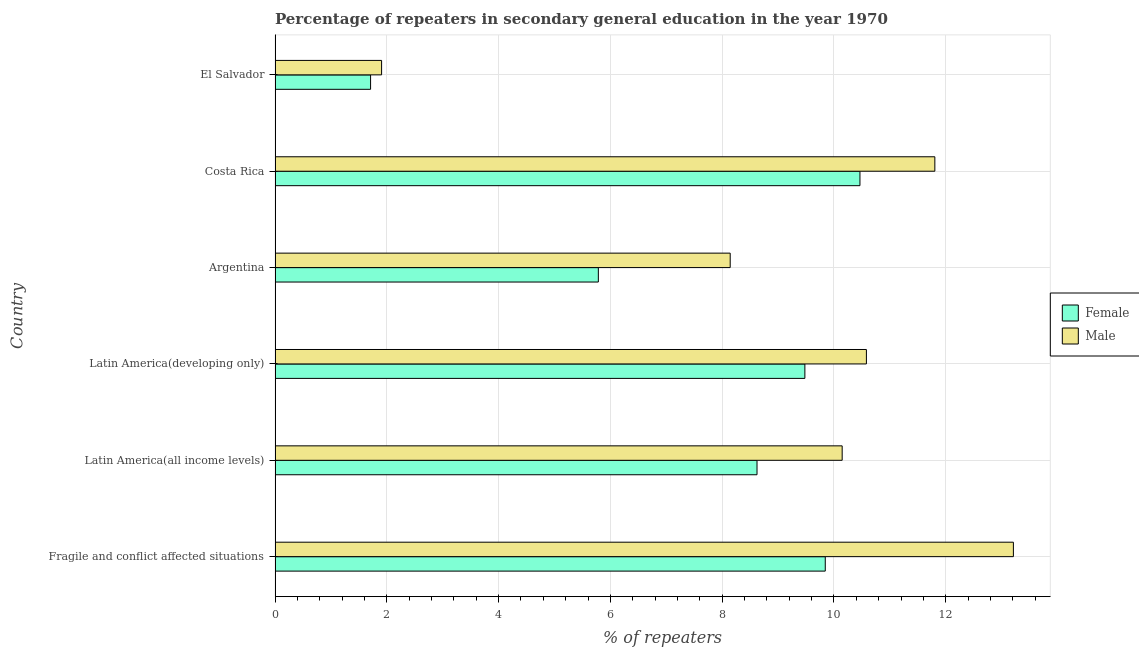How many different coloured bars are there?
Provide a short and direct response. 2. How many groups of bars are there?
Make the answer very short. 6. How many bars are there on the 5th tick from the bottom?
Make the answer very short. 2. In how many cases, is the number of bars for a given country not equal to the number of legend labels?
Provide a short and direct response. 0. What is the percentage of male repeaters in El Salvador?
Give a very brief answer. 1.91. Across all countries, what is the maximum percentage of female repeaters?
Ensure brevity in your answer.  10.47. Across all countries, what is the minimum percentage of male repeaters?
Make the answer very short. 1.91. In which country was the percentage of female repeaters minimum?
Your answer should be very brief. El Salvador. What is the total percentage of male repeaters in the graph?
Offer a very short reply. 55.79. What is the difference between the percentage of female repeaters in Costa Rica and that in Latin America(all income levels)?
Offer a terse response. 1.84. What is the difference between the percentage of female repeaters in Argentina and the percentage of male repeaters in Fragile and conflict affected situations?
Your answer should be very brief. -7.43. What is the average percentage of female repeaters per country?
Ensure brevity in your answer.  7.65. What is the difference between the percentage of female repeaters and percentage of male repeaters in Latin America(developing only)?
Offer a terse response. -1.1. What is the ratio of the percentage of male repeaters in El Salvador to that in Fragile and conflict affected situations?
Ensure brevity in your answer.  0.14. Is the percentage of female repeaters in El Salvador less than that in Latin America(developing only)?
Offer a terse response. Yes. What is the difference between the highest and the second highest percentage of female repeaters?
Provide a succinct answer. 0.62. What is the difference between the highest and the lowest percentage of female repeaters?
Offer a terse response. 8.76. In how many countries, is the percentage of female repeaters greater than the average percentage of female repeaters taken over all countries?
Make the answer very short. 4. Is the sum of the percentage of male repeaters in El Salvador and Latin America(all income levels) greater than the maximum percentage of female repeaters across all countries?
Keep it short and to the point. Yes. What does the 1st bar from the bottom in Costa Rica represents?
Ensure brevity in your answer.  Female. How many bars are there?
Your answer should be compact. 12. How many countries are there in the graph?
Ensure brevity in your answer.  6. What is the difference between two consecutive major ticks on the X-axis?
Give a very brief answer. 2. Are the values on the major ticks of X-axis written in scientific E-notation?
Your answer should be very brief. No. Does the graph contain any zero values?
Provide a short and direct response. No. How many legend labels are there?
Provide a short and direct response. 2. How are the legend labels stacked?
Your answer should be compact. Vertical. What is the title of the graph?
Your response must be concise. Percentage of repeaters in secondary general education in the year 1970. Does "Official aid received" appear as one of the legend labels in the graph?
Your answer should be very brief. No. What is the label or title of the X-axis?
Your answer should be compact. % of repeaters. What is the label or title of the Y-axis?
Your answer should be compact. Country. What is the % of repeaters in Female in Fragile and conflict affected situations?
Your response must be concise. 9.84. What is the % of repeaters in Male in Fragile and conflict affected situations?
Keep it short and to the point. 13.21. What is the % of repeaters of Female in Latin America(all income levels)?
Provide a succinct answer. 8.62. What is the % of repeaters in Male in Latin America(all income levels)?
Provide a short and direct response. 10.15. What is the % of repeaters in Female in Latin America(developing only)?
Your answer should be very brief. 9.48. What is the % of repeaters in Male in Latin America(developing only)?
Offer a very short reply. 10.58. What is the % of repeaters of Female in Argentina?
Your answer should be very brief. 5.78. What is the % of repeaters in Male in Argentina?
Give a very brief answer. 8.14. What is the % of repeaters in Female in Costa Rica?
Keep it short and to the point. 10.47. What is the % of repeaters of Male in Costa Rica?
Your answer should be very brief. 11.81. What is the % of repeaters in Female in El Salvador?
Offer a very short reply. 1.71. What is the % of repeaters in Male in El Salvador?
Keep it short and to the point. 1.91. Across all countries, what is the maximum % of repeaters in Female?
Offer a very short reply. 10.47. Across all countries, what is the maximum % of repeaters in Male?
Your answer should be very brief. 13.21. Across all countries, what is the minimum % of repeaters in Female?
Offer a terse response. 1.71. Across all countries, what is the minimum % of repeaters in Male?
Your answer should be very brief. 1.91. What is the total % of repeaters in Female in the graph?
Make the answer very short. 45.91. What is the total % of repeaters in Male in the graph?
Make the answer very short. 55.79. What is the difference between the % of repeaters of Female in Fragile and conflict affected situations and that in Latin America(all income levels)?
Keep it short and to the point. 1.22. What is the difference between the % of repeaters in Male in Fragile and conflict affected situations and that in Latin America(all income levels)?
Give a very brief answer. 3.06. What is the difference between the % of repeaters in Female in Fragile and conflict affected situations and that in Latin America(developing only)?
Your answer should be compact. 0.36. What is the difference between the % of repeaters in Male in Fragile and conflict affected situations and that in Latin America(developing only)?
Ensure brevity in your answer.  2.63. What is the difference between the % of repeaters of Female in Fragile and conflict affected situations and that in Argentina?
Make the answer very short. 4.06. What is the difference between the % of repeaters in Male in Fragile and conflict affected situations and that in Argentina?
Provide a succinct answer. 5.07. What is the difference between the % of repeaters of Female in Fragile and conflict affected situations and that in Costa Rica?
Make the answer very short. -0.62. What is the difference between the % of repeaters in Male in Fragile and conflict affected situations and that in Costa Rica?
Give a very brief answer. 1.41. What is the difference between the % of repeaters of Female in Fragile and conflict affected situations and that in El Salvador?
Your answer should be compact. 8.14. What is the difference between the % of repeaters in Male in Fragile and conflict affected situations and that in El Salvador?
Your answer should be compact. 11.31. What is the difference between the % of repeaters of Female in Latin America(all income levels) and that in Latin America(developing only)?
Your answer should be very brief. -0.86. What is the difference between the % of repeaters in Male in Latin America(all income levels) and that in Latin America(developing only)?
Ensure brevity in your answer.  -0.43. What is the difference between the % of repeaters in Female in Latin America(all income levels) and that in Argentina?
Give a very brief answer. 2.84. What is the difference between the % of repeaters of Male in Latin America(all income levels) and that in Argentina?
Ensure brevity in your answer.  2. What is the difference between the % of repeaters of Female in Latin America(all income levels) and that in Costa Rica?
Your answer should be very brief. -1.84. What is the difference between the % of repeaters of Male in Latin America(all income levels) and that in Costa Rica?
Your answer should be compact. -1.66. What is the difference between the % of repeaters in Female in Latin America(all income levels) and that in El Salvador?
Provide a short and direct response. 6.91. What is the difference between the % of repeaters in Male in Latin America(all income levels) and that in El Salvador?
Give a very brief answer. 8.24. What is the difference between the % of repeaters of Female in Latin America(developing only) and that in Argentina?
Make the answer very short. 3.7. What is the difference between the % of repeaters of Male in Latin America(developing only) and that in Argentina?
Your answer should be very brief. 2.44. What is the difference between the % of repeaters in Female in Latin America(developing only) and that in Costa Rica?
Your answer should be compact. -0.99. What is the difference between the % of repeaters of Male in Latin America(developing only) and that in Costa Rica?
Ensure brevity in your answer.  -1.22. What is the difference between the % of repeaters of Female in Latin America(developing only) and that in El Salvador?
Your response must be concise. 7.77. What is the difference between the % of repeaters of Male in Latin America(developing only) and that in El Salvador?
Make the answer very short. 8.68. What is the difference between the % of repeaters in Female in Argentina and that in Costa Rica?
Your answer should be very brief. -4.68. What is the difference between the % of repeaters in Male in Argentina and that in Costa Rica?
Your response must be concise. -3.66. What is the difference between the % of repeaters of Female in Argentina and that in El Salvador?
Your answer should be compact. 4.08. What is the difference between the % of repeaters of Male in Argentina and that in El Salvador?
Give a very brief answer. 6.24. What is the difference between the % of repeaters in Female in Costa Rica and that in El Salvador?
Keep it short and to the point. 8.76. What is the difference between the % of repeaters of Male in Costa Rica and that in El Salvador?
Make the answer very short. 9.9. What is the difference between the % of repeaters in Female in Fragile and conflict affected situations and the % of repeaters in Male in Latin America(all income levels)?
Provide a short and direct response. -0.3. What is the difference between the % of repeaters of Female in Fragile and conflict affected situations and the % of repeaters of Male in Latin America(developing only)?
Provide a short and direct response. -0.74. What is the difference between the % of repeaters of Female in Fragile and conflict affected situations and the % of repeaters of Male in Argentina?
Offer a very short reply. 1.7. What is the difference between the % of repeaters in Female in Fragile and conflict affected situations and the % of repeaters in Male in Costa Rica?
Give a very brief answer. -1.96. What is the difference between the % of repeaters in Female in Fragile and conflict affected situations and the % of repeaters in Male in El Salvador?
Make the answer very short. 7.94. What is the difference between the % of repeaters of Female in Latin America(all income levels) and the % of repeaters of Male in Latin America(developing only)?
Offer a very short reply. -1.96. What is the difference between the % of repeaters in Female in Latin America(all income levels) and the % of repeaters in Male in Argentina?
Keep it short and to the point. 0.48. What is the difference between the % of repeaters in Female in Latin America(all income levels) and the % of repeaters in Male in Costa Rica?
Offer a terse response. -3.18. What is the difference between the % of repeaters of Female in Latin America(all income levels) and the % of repeaters of Male in El Salvador?
Offer a very short reply. 6.72. What is the difference between the % of repeaters in Female in Latin America(developing only) and the % of repeaters in Male in Argentina?
Your answer should be compact. 1.34. What is the difference between the % of repeaters in Female in Latin America(developing only) and the % of repeaters in Male in Costa Rica?
Offer a terse response. -2.33. What is the difference between the % of repeaters in Female in Latin America(developing only) and the % of repeaters in Male in El Salvador?
Offer a very short reply. 7.57. What is the difference between the % of repeaters of Female in Argentina and the % of repeaters of Male in Costa Rica?
Your answer should be very brief. -6.02. What is the difference between the % of repeaters in Female in Argentina and the % of repeaters in Male in El Salvador?
Keep it short and to the point. 3.88. What is the difference between the % of repeaters of Female in Costa Rica and the % of repeaters of Male in El Salvador?
Your answer should be very brief. 8.56. What is the average % of repeaters in Female per country?
Make the answer very short. 7.65. What is the average % of repeaters in Male per country?
Keep it short and to the point. 9.3. What is the difference between the % of repeaters in Female and % of repeaters in Male in Fragile and conflict affected situations?
Your answer should be very brief. -3.37. What is the difference between the % of repeaters of Female and % of repeaters of Male in Latin America(all income levels)?
Provide a succinct answer. -1.52. What is the difference between the % of repeaters in Female and % of repeaters in Male in Latin America(developing only)?
Your answer should be compact. -1.1. What is the difference between the % of repeaters of Female and % of repeaters of Male in Argentina?
Give a very brief answer. -2.36. What is the difference between the % of repeaters in Female and % of repeaters in Male in Costa Rica?
Keep it short and to the point. -1.34. What is the difference between the % of repeaters of Female and % of repeaters of Male in El Salvador?
Provide a short and direct response. -0.2. What is the ratio of the % of repeaters in Female in Fragile and conflict affected situations to that in Latin America(all income levels)?
Keep it short and to the point. 1.14. What is the ratio of the % of repeaters of Male in Fragile and conflict affected situations to that in Latin America(all income levels)?
Your response must be concise. 1.3. What is the ratio of the % of repeaters of Female in Fragile and conflict affected situations to that in Latin America(developing only)?
Keep it short and to the point. 1.04. What is the ratio of the % of repeaters in Male in Fragile and conflict affected situations to that in Latin America(developing only)?
Make the answer very short. 1.25. What is the ratio of the % of repeaters in Female in Fragile and conflict affected situations to that in Argentina?
Give a very brief answer. 1.7. What is the ratio of the % of repeaters in Male in Fragile and conflict affected situations to that in Argentina?
Provide a succinct answer. 1.62. What is the ratio of the % of repeaters in Female in Fragile and conflict affected situations to that in Costa Rica?
Your response must be concise. 0.94. What is the ratio of the % of repeaters in Male in Fragile and conflict affected situations to that in Costa Rica?
Your answer should be very brief. 1.12. What is the ratio of the % of repeaters of Female in Fragile and conflict affected situations to that in El Salvador?
Your answer should be very brief. 5.76. What is the ratio of the % of repeaters in Male in Fragile and conflict affected situations to that in El Salvador?
Provide a short and direct response. 6.93. What is the ratio of the % of repeaters of Female in Latin America(all income levels) to that in Latin America(developing only)?
Your answer should be very brief. 0.91. What is the ratio of the % of repeaters of Male in Latin America(all income levels) to that in Latin America(developing only)?
Keep it short and to the point. 0.96. What is the ratio of the % of repeaters of Female in Latin America(all income levels) to that in Argentina?
Offer a very short reply. 1.49. What is the ratio of the % of repeaters in Male in Latin America(all income levels) to that in Argentina?
Make the answer very short. 1.25. What is the ratio of the % of repeaters of Female in Latin America(all income levels) to that in Costa Rica?
Your response must be concise. 0.82. What is the ratio of the % of repeaters of Male in Latin America(all income levels) to that in Costa Rica?
Your answer should be very brief. 0.86. What is the ratio of the % of repeaters of Female in Latin America(all income levels) to that in El Salvador?
Give a very brief answer. 5.05. What is the ratio of the % of repeaters of Male in Latin America(all income levels) to that in El Salvador?
Ensure brevity in your answer.  5.32. What is the ratio of the % of repeaters of Female in Latin America(developing only) to that in Argentina?
Keep it short and to the point. 1.64. What is the ratio of the % of repeaters of Male in Latin America(developing only) to that in Argentina?
Make the answer very short. 1.3. What is the ratio of the % of repeaters in Female in Latin America(developing only) to that in Costa Rica?
Your answer should be very brief. 0.91. What is the ratio of the % of repeaters in Male in Latin America(developing only) to that in Costa Rica?
Give a very brief answer. 0.9. What is the ratio of the % of repeaters of Female in Latin America(developing only) to that in El Salvador?
Offer a terse response. 5.55. What is the ratio of the % of repeaters of Male in Latin America(developing only) to that in El Salvador?
Make the answer very short. 5.55. What is the ratio of the % of repeaters in Female in Argentina to that in Costa Rica?
Your answer should be compact. 0.55. What is the ratio of the % of repeaters in Male in Argentina to that in Costa Rica?
Offer a very short reply. 0.69. What is the ratio of the % of repeaters in Female in Argentina to that in El Salvador?
Keep it short and to the point. 3.38. What is the ratio of the % of repeaters in Male in Argentina to that in El Salvador?
Provide a succinct answer. 4.27. What is the ratio of the % of repeaters of Female in Costa Rica to that in El Salvador?
Keep it short and to the point. 6.12. What is the ratio of the % of repeaters in Male in Costa Rica to that in El Salvador?
Provide a short and direct response. 6.19. What is the difference between the highest and the second highest % of repeaters in Female?
Your response must be concise. 0.62. What is the difference between the highest and the second highest % of repeaters in Male?
Provide a succinct answer. 1.41. What is the difference between the highest and the lowest % of repeaters in Female?
Offer a terse response. 8.76. What is the difference between the highest and the lowest % of repeaters of Male?
Give a very brief answer. 11.31. 